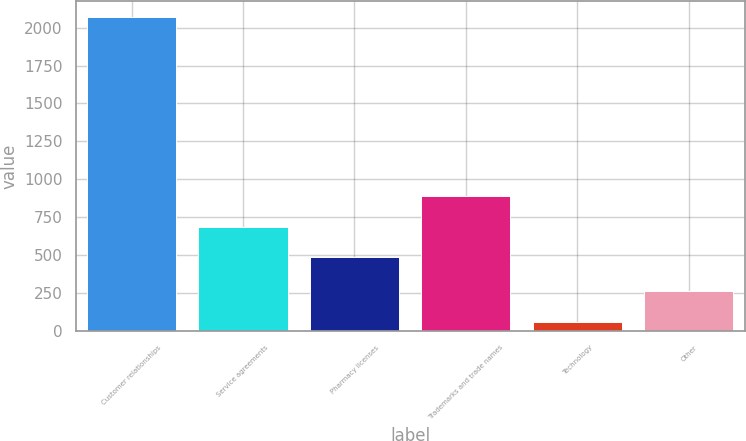Convert chart. <chart><loc_0><loc_0><loc_500><loc_500><bar_chart><fcel>Customer relationships<fcel>Service agreements<fcel>Pharmacy licenses<fcel>Trademarks and trade names<fcel>Technology<fcel>Other<nl><fcel>2069<fcel>688.6<fcel>488<fcel>889.2<fcel>63<fcel>263.6<nl></chart> 